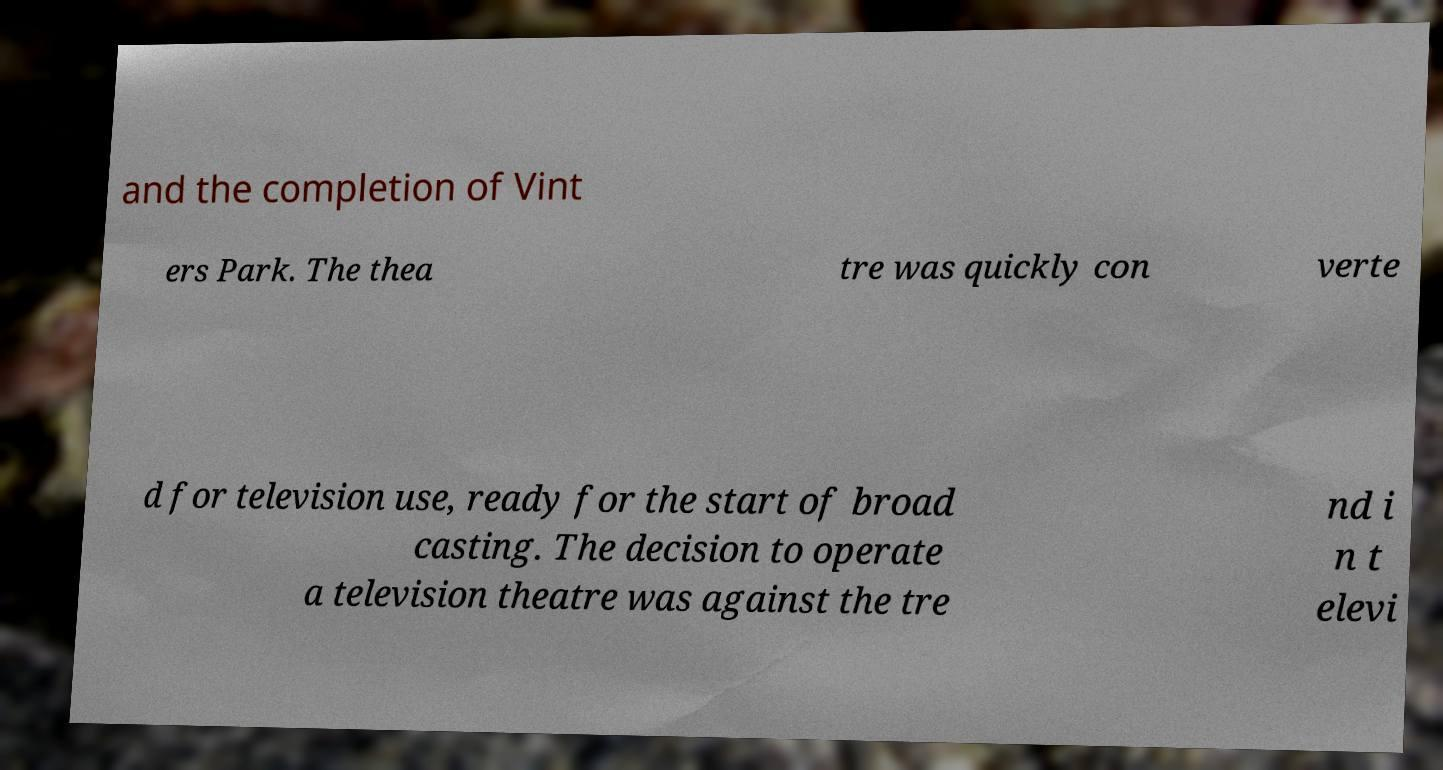Please read and relay the text visible in this image. What does it say? and the completion of Vint ers Park. The thea tre was quickly con verte d for television use, ready for the start of broad casting. The decision to operate a television theatre was against the tre nd i n t elevi 